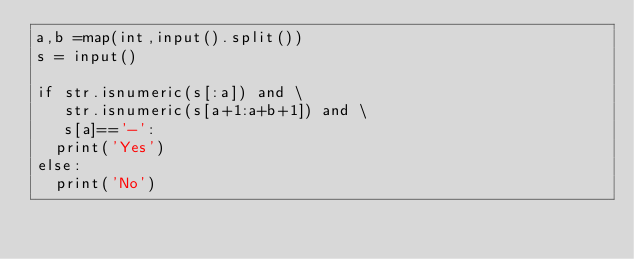<code> <loc_0><loc_0><loc_500><loc_500><_Python_>a,b =map(int,input().split())
s = input()

if str.isnumeric(s[:a]) and \
   str.isnumeric(s[a+1:a+b+1]) and \
   s[a]=='-':  
  print('Yes')
else:
  print('No')</code> 